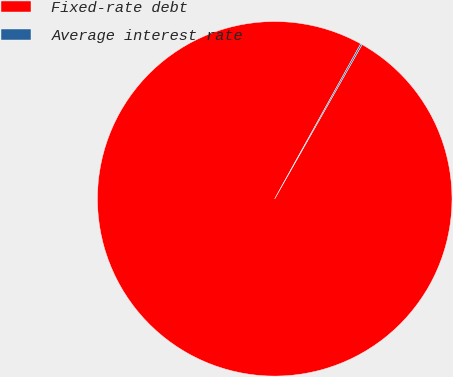<chart> <loc_0><loc_0><loc_500><loc_500><pie_chart><fcel>Fixed-rate debt<fcel>Average interest rate<nl><fcel>99.86%<fcel>0.14%<nl></chart> 